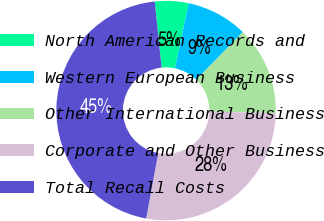<chart> <loc_0><loc_0><loc_500><loc_500><pie_chart><fcel>North American Records and<fcel>Western European Business<fcel>Other International Business<fcel>Corporate and Other Business<fcel>Total Recall Costs<nl><fcel>4.96%<fcel>9.01%<fcel>13.05%<fcel>27.54%<fcel>45.44%<nl></chart> 